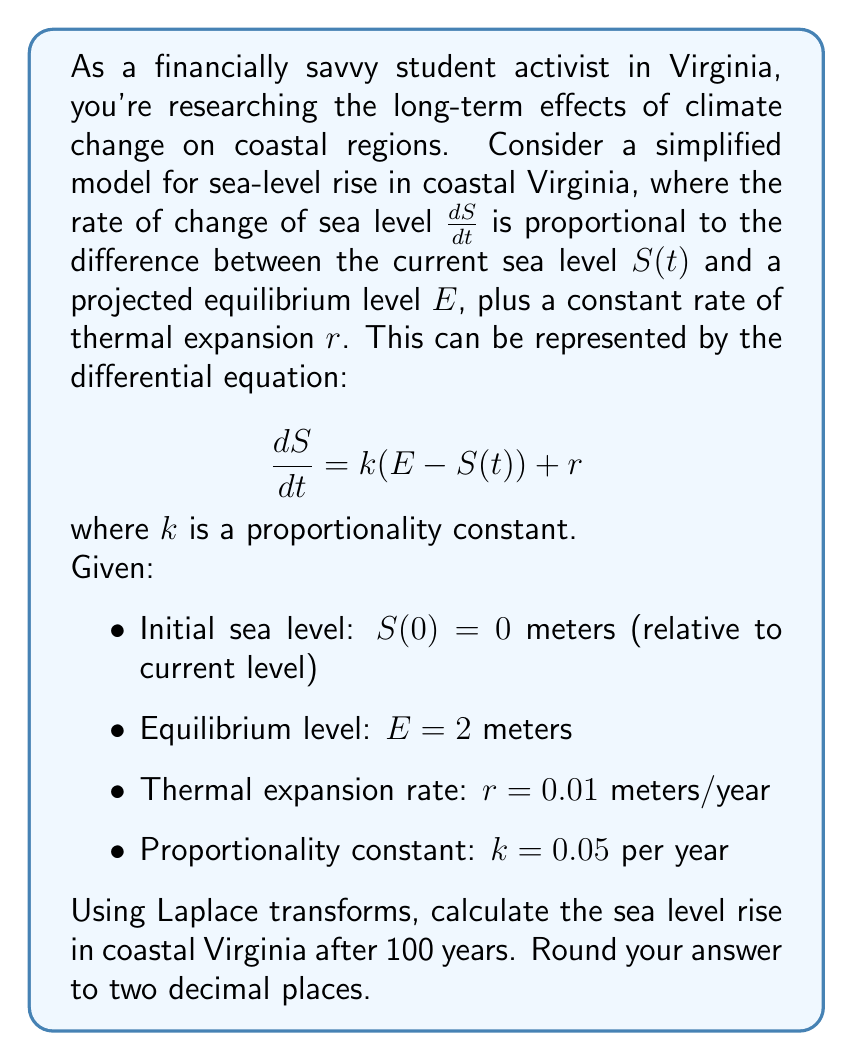Help me with this question. Let's solve this step-by-step using Laplace transforms:

1) First, we take the Laplace transform of both sides of the equation:

   $$\mathcal{L}\left\{\frac{dS}{dt}\right\} = \mathcal{L}\{k(E - S(t)) + r\}$$

2) Using Laplace transform properties:

   $$s\mathcal{L}\{S(t)\} - S(0) = kE\mathcal{L}\{1\} - k\mathcal{L}\{S(t)\} + r\mathcal{L}\{1\}$$

3) Simplify, using $\mathcal{L}\{1\} = \frac{1}{s}$ and $S(0) = 0$:

   $$s\mathcal{L}\{S(t)\} = \frac{kE}{s} - k\mathcal{L}\{S(t)\} + \frac{r}{s}$$

4) Rearrange terms:

   $$(s + k)\mathcal{L}\{S(t)\} = \frac{kE + r}{s}$$

5) Solve for $\mathcal{L}\{S(t)\}$:

   $$\mathcal{L}\{S(t)\} = \frac{kE + r}{s(s + k)}$$

6) Perform partial fraction decomposition:

   $$\mathcal{L}\{S(t)\} = \frac{A}{s} + \frac{B}{s + k}$$

   where $A = \frac{kE + r}{k} = E + \frac{r}{k}$ and $B = -\frac{kE + r}{k} = -E - \frac{r}{k}$

7) Take the inverse Laplace transform:

   $$S(t) = \mathcal{L}^{-1}\left\{\frac{A}{s} + \frac{B}{s + k}\right\} = A + Be^{-kt}$$

8) Substitute the values:

   $$S(t) = \left(2 + \frac{0.01}{0.05}\right) + \left(-2 - \frac{0.01}{0.05}\right)e^{-0.05t}$$

   $$S(t) = 2.2 - 2.2e^{-0.05t}$$

9) To find the sea level rise after 100 years, evaluate $S(100)$:

   $$S(100) = 2.2 - 2.2e^{-0.05(100)} \approx 2.18$$ meters
Answer: 2.18 meters 